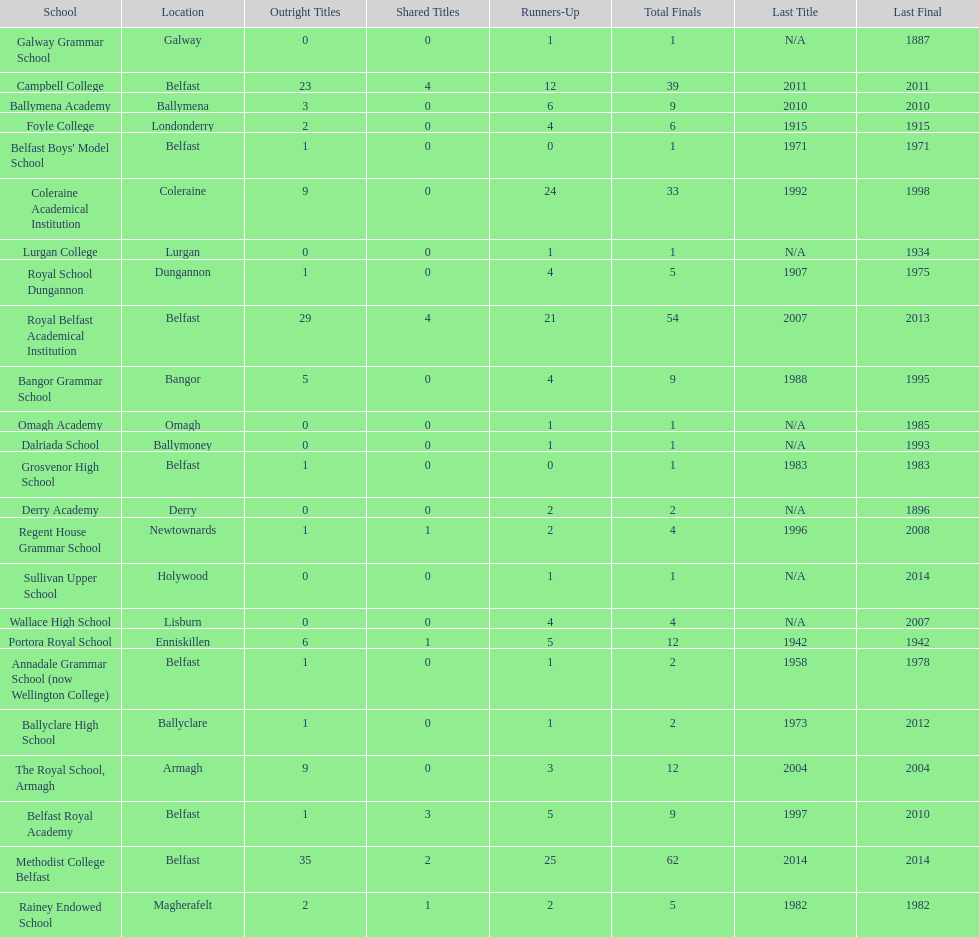How many schools had above 5 outright titles? 6. 